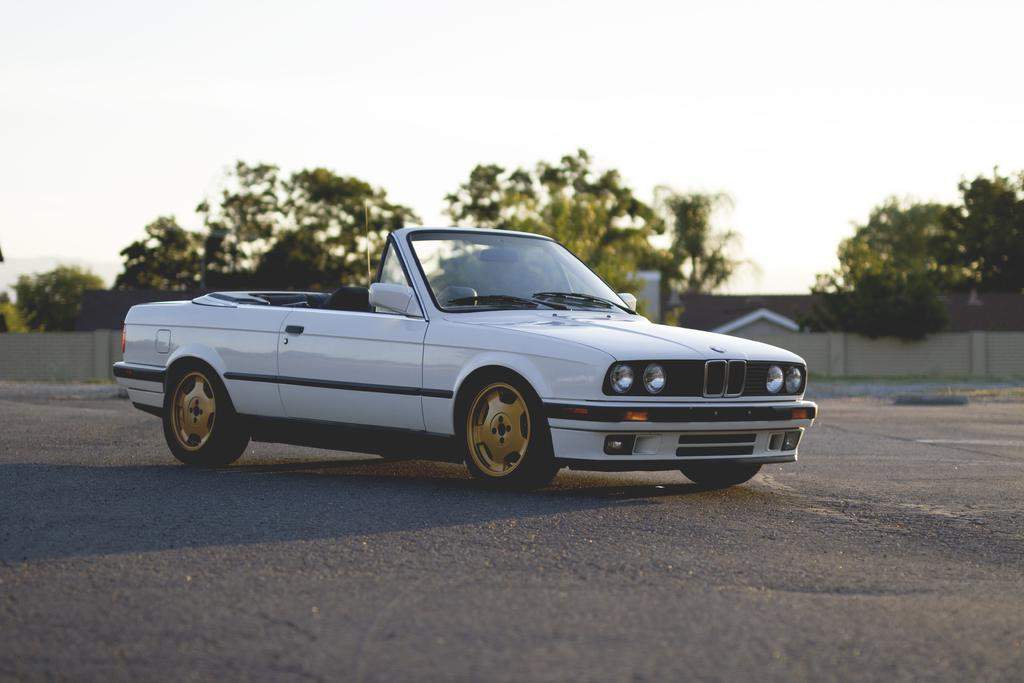What type of vehicle is on the road in the image? There is a white car on the road in the image. What can be seen in the background of the image? There are many trees in the image. Where is the house located in the image? There is a house at the right center of the image. Can you see a snail climbing on the white car in the image? There is no snail present on the white car in the image. Is there a fireman standing next to the house in the image? There is no fireman present in the image. 